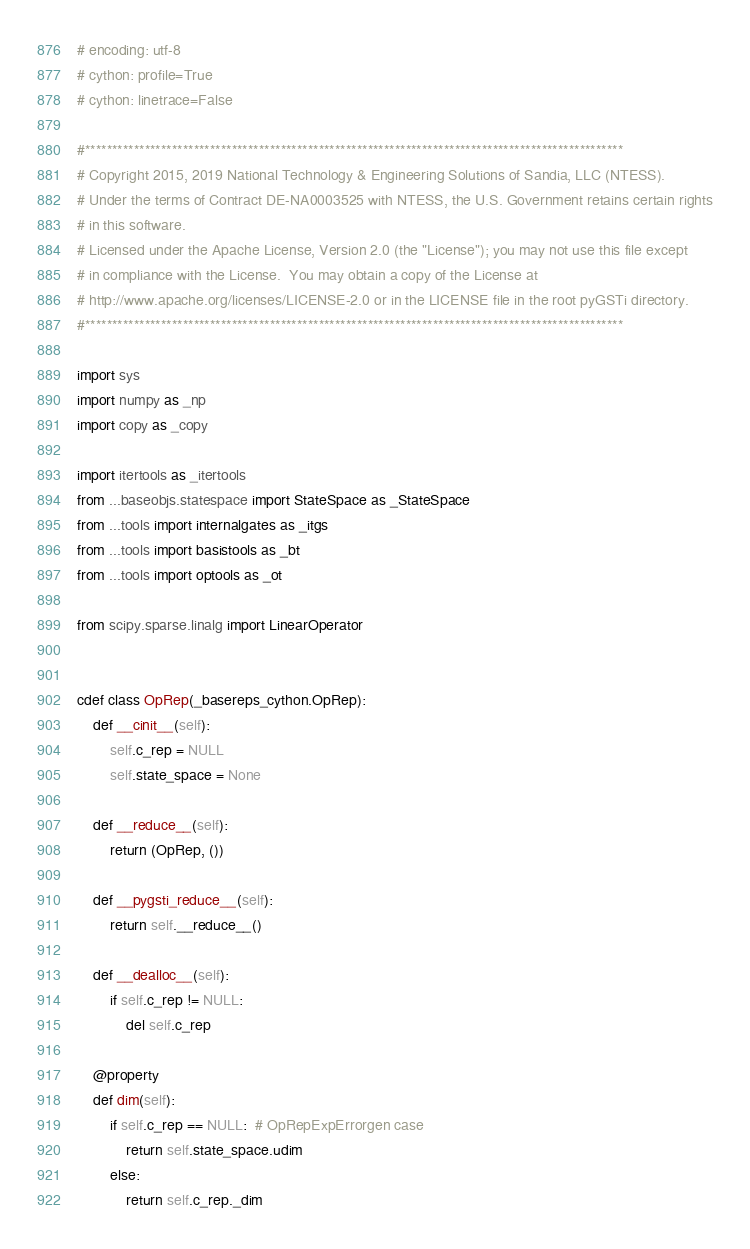<code> <loc_0><loc_0><loc_500><loc_500><_Cython_># encoding: utf-8
# cython: profile=True
# cython: linetrace=False

#***************************************************************************************************
# Copyright 2015, 2019 National Technology & Engineering Solutions of Sandia, LLC (NTESS).
# Under the terms of Contract DE-NA0003525 with NTESS, the U.S. Government retains certain rights
# in this software.
# Licensed under the Apache License, Version 2.0 (the "License"); you may not use this file except
# in compliance with the License.  You may obtain a copy of the License at
# http://www.apache.org/licenses/LICENSE-2.0 or in the LICENSE file in the root pyGSTi directory.
#***************************************************************************************************

import sys
import numpy as _np
import copy as _copy

import itertools as _itertools
from ...baseobjs.statespace import StateSpace as _StateSpace
from ...tools import internalgates as _itgs
from ...tools import basistools as _bt
from ...tools import optools as _ot

from scipy.sparse.linalg import LinearOperator


cdef class OpRep(_basereps_cython.OpRep):
    def __cinit__(self):
        self.c_rep = NULL
        self.state_space = None

    def __reduce__(self):
        return (OpRep, ())

    def __pygsti_reduce__(self):
        return self.__reduce__()

    def __dealloc__(self):
        if self.c_rep != NULL:
            del self.c_rep

    @property
    def dim(self):
        if self.c_rep == NULL:  # OpRepExpErrorgen case
            return self.state_space.udim
        else:
            return self.c_rep._dim
</code> 